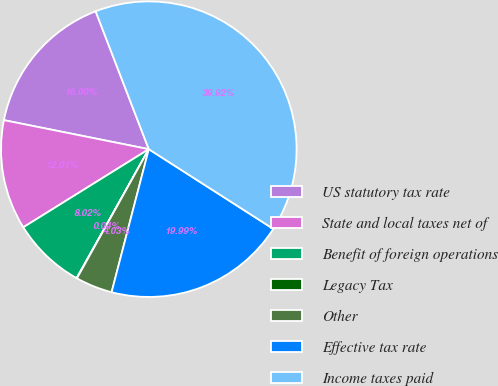<chart> <loc_0><loc_0><loc_500><loc_500><pie_chart><fcel>US statutory tax rate<fcel>State and local taxes net of<fcel>Benefit of foreign operations<fcel>Legacy Tax<fcel>Other<fcel>Effective tax rate<fcel>Income taxes paid<nl><fcel>16.0%<fcel>12.01%<fcel>8.02%<fcel>0.04%<fcel>4.03%<fcel>19.99%<fcel>39.93%<nl></chart> 